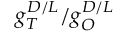<formula> <loc_0><loc_0><loc_500><loc_500>g _ { T } ^ { D / L } / g _ { O } ^ { D / L }</formula> 